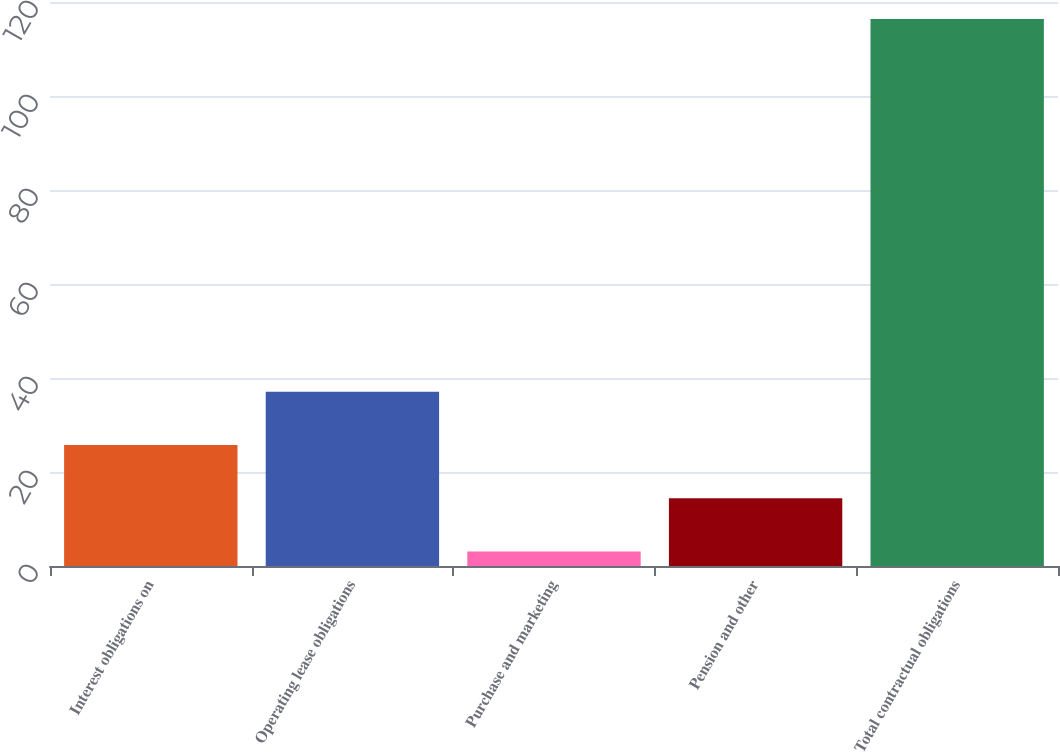<chart> <loc_0><loc_0><loc_500><loc_500><bar_chart><fcel>Interest obligations on<fcel>Operating lease obligations<fcel>Purchase and marketing<fcel>Pension and other<fcel>Total contractual obligations<nl><fcel>25.76<fcel>37.09<fcel>3.1<fcel>14.43<fcel>116.4<nl></chart> 